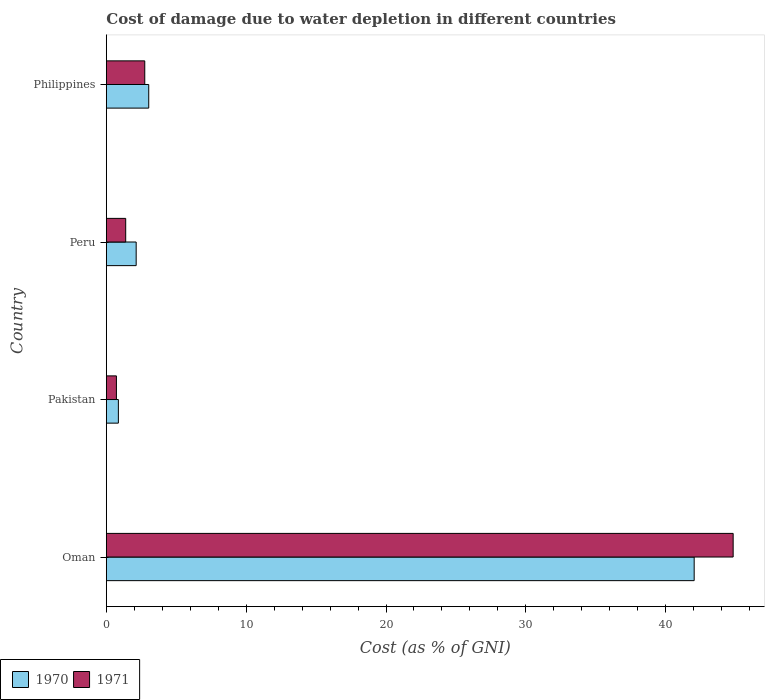How many different coloured bars are there?
Your answer should be very brief. 2. Are the number of bars on each tick of the Y-axis equal?
Your answer should be compact. Yes. How many bars are there on the 2nd tick from the top?
Ensure brevity in your answer.  2. What is the label of the 3rd group of bars from the top?
Make the answer very short. Pakistan. In how many cases, is the number of bars for a given country not equal to the number of legend labels?
Your response must be concise. 0. What is the cost of damage caused due to water depletion in 1971 in Pakistan?
Give a very brief answer. 0.72. Across all countries, what is the maximum cost of damage caused due to water depletion in 1970?
Ensure brevity in your answer.  42.04. Across all countries, what is the minimum cost of damage caused due to water depletion in 1970?
Provide a succinct answer. 0.86. In which country was the cost of damage caused due to water depletion in 1970 maximum?
Offer a very short reply. Oman. In which country was the cost of damage caused due to water depletion in 1971 minimum?
Ensure brevity in your answer.  Pakistan. What is the total cost of damage caused due to water depletion in 1971 in the graph?
Your response must be concise. 49.68. What is the difference between the cost of damage caused due to water depletion in 1971 in Oman and that in Pakistan?
Make the answer very short. 44.1. What is the difference between the cost of damage caused due to water depletion in 1971 in Philippines and the cost of damage caused due to water depletion in 1970 in Peru?
Keep it short and to the point. 0.62. What is the average cost of damage caused due to water depletion in 1971 per country?
Make the answer very short. 12.42. What is the difference between the cost of damage caused due to water depletion in 1971 and cost of damage caused due to water depletion in 1970 in Oman?
Offer a terse response. 2.79. What is the ratio of the cost of damage caused due to water depletion in 1971 in Pakistan to that in Peru?
Offer a terse response. 0.52. Is the cost of damage caused due to water depletion in 1971 in Oman less than that in Peru?
Keep it short and to the point. No. Is the difference between the cost of damage caused due to water depletion in 1971 in Oman and Pakistan greater than the difference between the cost of damage caused due to water depletion in 1970 in Oman and Pakistan?
Give a very brief answer. Yes. What is the difference between the highest and the second highest cost of damage caused due to water depletion in 1971?
Provide a succinct answer. 42.08. What is the difference between the highest and the lowest cost of damage caused due to water depletion in 1971?
Your answer should be compact. 44.1. What does the 1st bar from the top in Pakistan represents?
Your response must be concise. 1971. What does the 1st bar from the bottom in Pakistan represents?
Your answer should be very brief. 1970. How many bars are there?
Your response must be concise. 8. How many countries are there in the graph?
Provide a succinct answer. 4. Are the values on the major ticks of X-axis written in scientific E-notation?
Ensure brevity in your answer.  No. Does the graph contain any zero values?
Ensure brevity in your answer.  No. Does the graph contain grids?
Provide a succinct answer. No. What is the title of the graph?
Offer a very short reply. Cost of damage due to water depletion in different countries. Does "1989" appear as one of the legend labels in the graph?
Give a very brief answer. No. What is the label or title of the X-axis?
Your answer should be very brief. Cost (as % of GNI). What is the Cost (as % of GNI) of 1970 in Oman?
Your answer should be very brief. 42.04. What is the Cost (as % of GNI) of 1971 in Oman?
Give a very brief answer. 44.83. What is the Cost (as % of GNI) of 1970 in Pakistan?
Your answer should be very brief. 0.86. What is the Cost (as % of GNI) of 1971 in Pakistan?
Give a very brief answer. 0.72. What is the Cost (as % of GNI) of 1970 in Peru?
Your answer should be compact. 2.13. What is the Cost (as % of GNI) of 1971 in Peru?
Your answer should be very brief. 1.39. What is the Cost (as % of GNI) of 1970 in Philippines?
Provide a succinct answer. 3.03. What is the Cost (as % of GNI) of 1971 in Philippines?
Your answer should be compact. 2.75. Across all countries, what is the maximum Cost (as % of GNI) of 1970?
Your answer should be very brief. 42.04. Across all countries, what is the maximum Cost (as % of GNI) in 1971?
Make the answer very short. 44.83. Across all countries, what is the minimum Cost (as % of GNI) in 1970?
Your response must be concise. 0.86. Across all countries, what is the minimum Cost (as % of GNI) in 1971?
Make the answer very short. 0.72. What is the total Cost (as % of GNI) of 1970 in the graph?
Give a very brief answer. 48.07. What is the total Cost (as % of GNI) in 1971 in the graph?
Keep it short and to the point. 49.68. What is the difference between the Cost (as % of GNI) of 1970 in Oman and that in Pakistan?
Give a very brief answer. 41.18. What is the difference between the Cost (as % of GNI) in 1971 in Oman and that in Pakistan?
Give a very brief answer. 44.1. What is the difference between the Cost (as % of GNI) in 1970 in Oman and that in Peru?
Keep it short and to the point. 39.9. What is the difference between the Cost (as % of GNI) of 1971 in Oman and that in Peru?
Your response must be concise. 43.44. What is the difference between the Cost (as % of GNI) of 1970 in Oman and that in Philippines?
Ensure brevity in your answer.  39.01. What is the difference between the Cost (as % of GNI) in 1971 in Oman and that in Philippines?
Make the answer very short. 42.08. What is the difference between the Cost (as % of GNI) in 1970 in Pakistan and that in Peru?
Offer a terse response. -1.27. What is the difference between the Cost (as % of GNI) in 1971 in Pakistan and that in Peru?
Ensure brevity in your answer.  -0.66. What is the difference between the Cost (as % of GNI) of 1970 in Pakistan and that in Philippines?
Ensure brevity in your answer.  -2.17. What is the difference between the Cost (as % of GNI) of 1971 in Pakistan and that in Philippines?
Give a very brief answer. -2.03. What is the difference between the Cost (as % of GNI) of 1970 in Peru and that in Philippines?
Provide a succinct answer. -0.9. What is the difference between the Cost (as % of GNI) in 1971 in Peru and that in Philippines?
Your answer should be compact. -1.36. What is the difference between the Cost (as % of GNI) in 1970 in Oman and the Cost (as % of GNI) in 1971 in Pakistan?
Offer a terse response. 41.32. What is the difference between the Cost (as % of GNI) in 1970 in Oman and the Cost (as % of GNI) in 1971 in Peru?
Provide a succinct answer. 40.65. What is the difference between the Cost (as % of GNI) of 1970 in Oman and the Cost (as % of GNI) of 1971 in Philippines?
Offer a terse response. 39.29. What is the difference between the Cost (as % of GNI) in 1970 in Pakistan and the Cost (as % of GNI) in 1971 in Peru?
Make the answer very short. -0.52. What is the difference between the Cost (as % of GNI) of 1970 in Pakistan and the Cost (as % of GNI) of 1971 in Philippines?
Keep it short and to the point. -1.89. What is the difference between the Cost (as % of GNI) in 1970 in Peru and the Cost (as % of GNI) in 1971 in Philippines?
Your response must be concise. -0.62. What is the average Cost (as % of GNI) in 1970 per country?
Offer a terse response. 12.02. What is the average Cost (as % of GNI) in 1971 per country?
Provide a short and direct response. 12.42. What is the difference between the Cost (as % of GNI) in 1970 and Cost (as % of GNI) in 1971 in Oman?
Your answer should be very brief. -2.79. What is the difference between the Cost (as % of GNI) in 1970 and Cost (as % of GNI) in 1971 in Pakistan?
Make the answer very short. 0.14. What is the difference between the Cost (as % of GNI) of 1970 and Cost (as % of GNI) of 1971 in Peru?
Keep it short and to the point. 0.75. What is the difference between the Cost (as % of GNI) in 1970 and Cost (as % of GNI) in 1971 in Philippines?
Make the answer very short. 0.28. What is the ratio of the Cost (as % of GNI) of 1970 in Oman to that in Pakistan?
Ensure brevity in your answer.  48.82. What is the ratio of the Cost (as % of GNI) of 1971 in Oman to that in Pakistan?
Provide a short and direct response. 62.14. What is the ratio of the Cost (as % of GNI) in 1970 in Oman to that in Peru?
Offer a very short reply. 19.7. What is the ratio of the Cost (as % of GNI) of 1971 in Oman to that in Peru?
Give a very brief answer. 32.36. What is the ratio of the Cost (as % of GNI) in 1970 in Oman to that in Philippines?
Keep it short and to the point. 13.86. What is the ratio of the Cost (as % of GNI) of 1971 in Oman to that in Philippines?
Offer a very short reply. 16.31. What is the ratio of the Cost (as % of GNI) in 1970 in Pakistan to that in Peru?
Provide a succinct answer. 0.4. What is the ratio of the Cost (as % of GNI) in 1971 in Pakistan to that in Peru?
Provide a succinct answer. 0.52. What is the ratio of the Cost (as % of GNI) of 1970 in Pakistan to that in Philippines?
Provide a short and direct response. 0.28. What is the ratio of the Cost (as % of GNI) of 1971 in Pakistan to that in Philippines?
Make the answer very short. 0.26. What is the ratio of the Cost (as % of GNI) in 1970 in Peru to that in Philippines?
Give a very brief answer. 0.7. What is the ratio of the Cost (as % of GNI) in 1971 in Peru to that in Philippines?
Offer a terse response. 0.5. What is the difference between the highest and the second highest Cost (as % of GNI) of 1970?
Your answer should be very brief. 39.01. What is the difference between the highest and the second highest Cost (as % of GNI) in 1971?
Your response must be concise. 42.08. What is the difference between the highest and the lowest Cost (as % of GNI) in 1970?
Offer a very short reply. 41.18. What is the difference between the highest and the lowest Cost (as % of GNI) in 1971?
Your response must be concise. 44.1. 